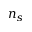<formula> <loc_0><loc_0><loc_500><loc_500>n _ { s }</formula> 